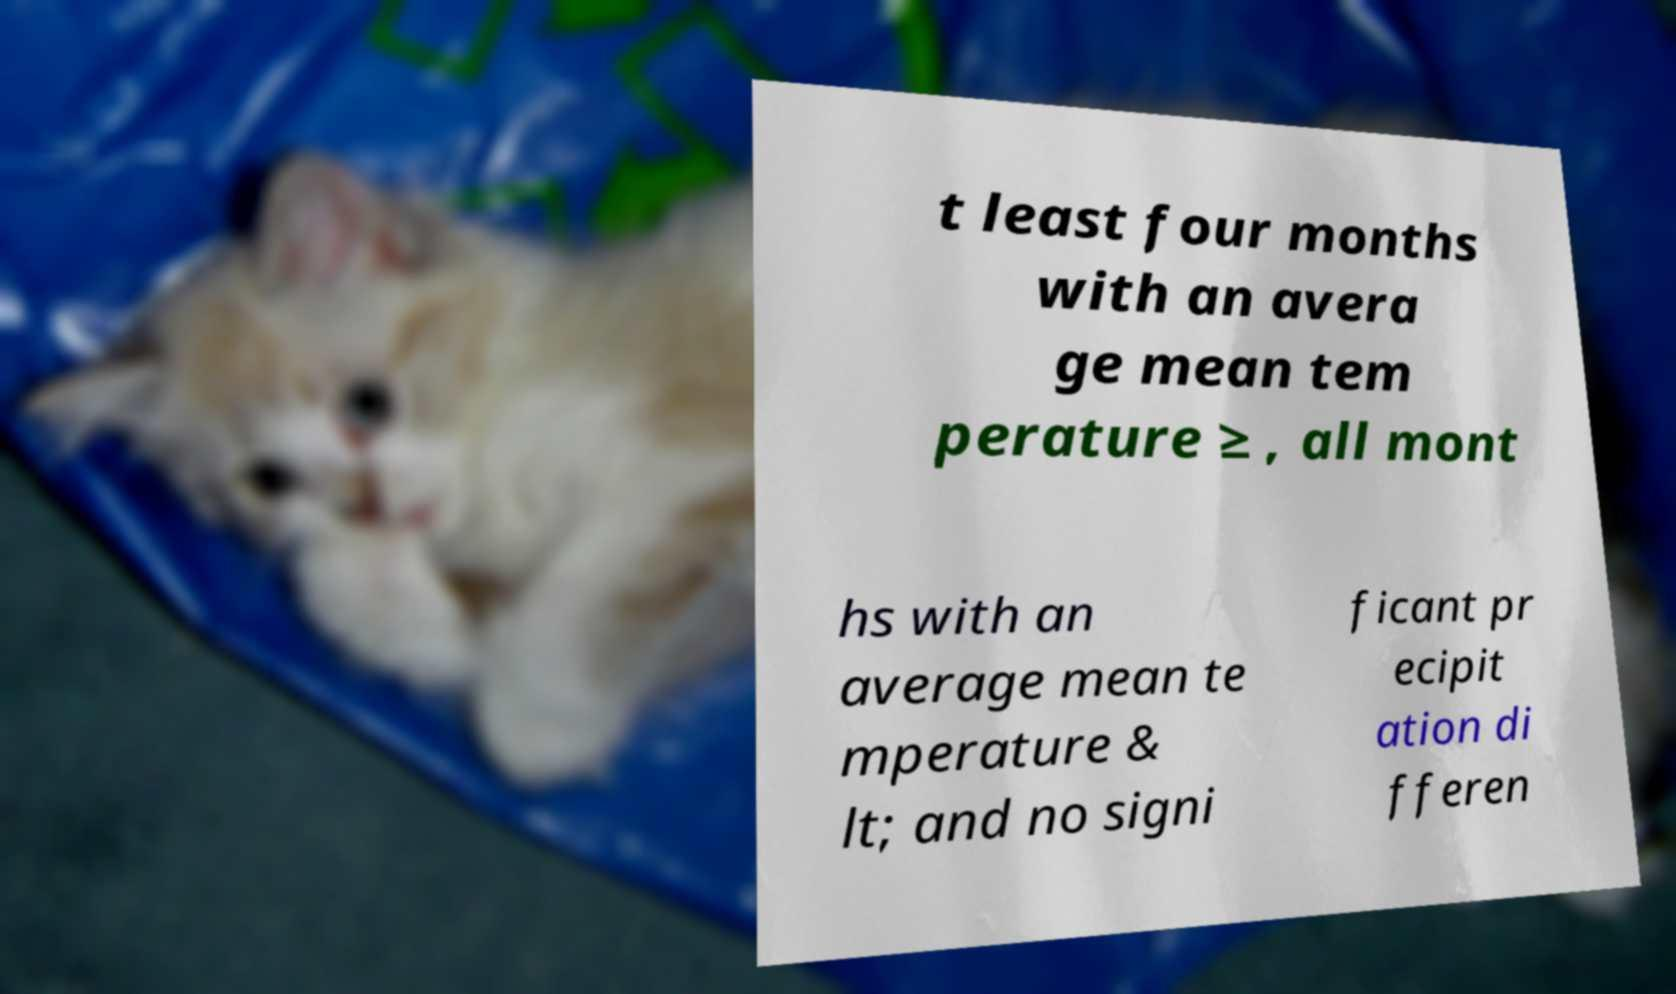Can you read and provide the text displayed in the image?This photo seems to have some interesting text. Can you extract and type it out for me? t least four months with an avera ge mean tem perature ≥ , all mont hs with an average mean te mperature & lt; and no signi ficant pr ecipit ation di fferen 